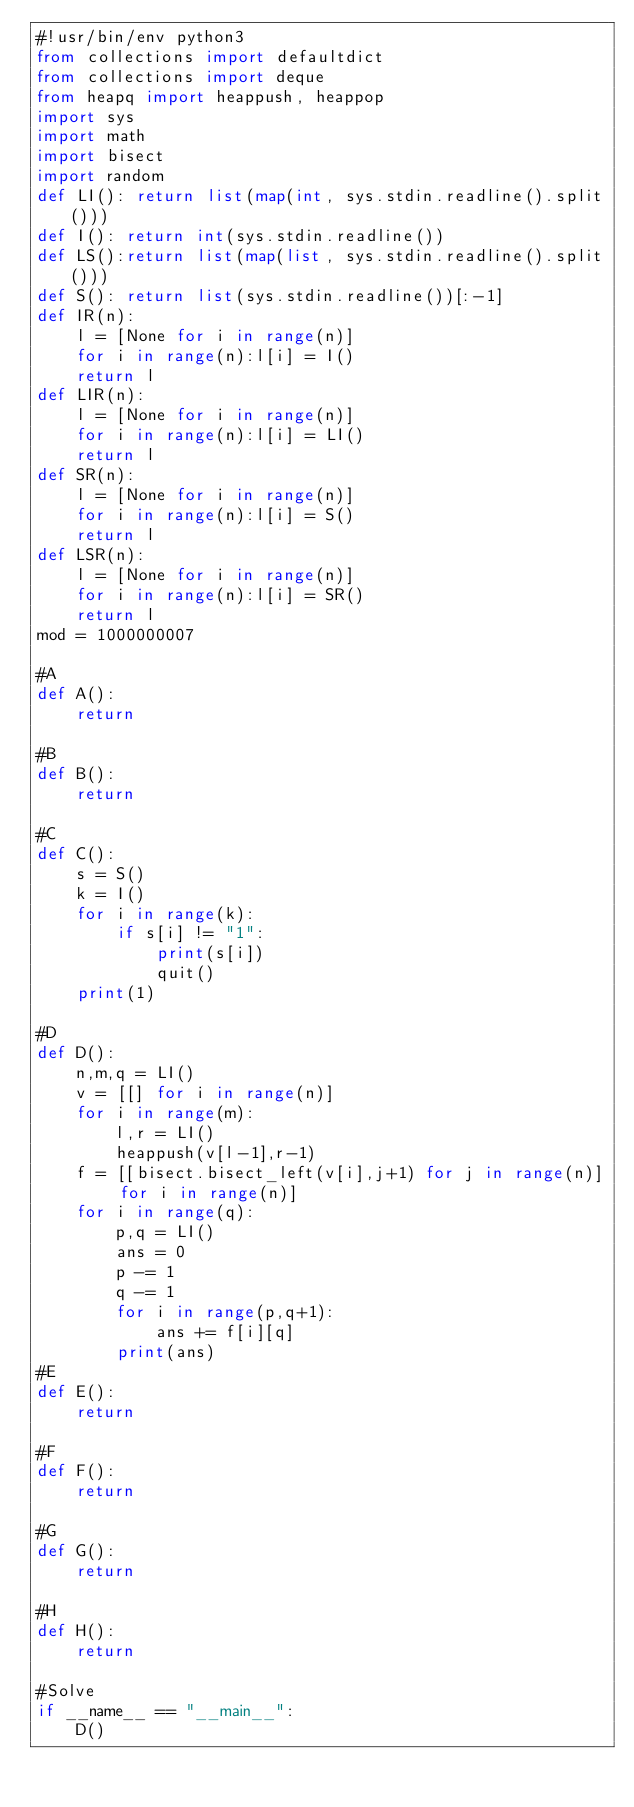Convert code to text. <code><loc_0><loc_0><loc_500><loc_500><_Python_>#!usr/bin/env python3
from collections import defaultdict
from collections import deque
from heapq import heappush, heappop
import sys
import math
import bisect
import random
def LI(): return list(map(int, sys.stdin.readline().split()))
def I(): return int(sys.stdin.readline())
def LS():return list(map(list, sys.stdin.readline().split()))
def S(): return list(sys.stdin.readline())[:-1]
def IR(n):
    l = [None for i in range(n)]
    for i in range(n):l[i] = I()
    return l
def LIR(n):
    l = [None for i in range(n)]
    for i in range(n):l[i] = LI()
    return l
def SR(n):
    l = [None for i in range(n)]
    for i in range(n):l[i] = S()
    return l
def LSR(n):
    l = [None for i in range(n)]
    for i in range(n):l[i] = SR()
    return l
mod = 1000000007

#A
def A():
    return

#B
def B():
    return

#C
def C():
    s = S()
    k = I()
    for i in range(k):
        if s[i] != "1":
            print(s[i])
            quit()
    print(1)

#D
def D():
    n,m,q = LI()
    v = [[] for i in range(n)]
    for i in range(m):
        l,r = LI()
        heappush(v[l-1],r-1)
    f = [[bisect.bisect_left(v[i],j+1) for j in range(n)] for i in range(n)]
    for i in range(q):
        p,q = LI()
        ans = 0
        p -= 1
        q -= 1
        for i in range(p,q+1):
            ans += f[i][q]
        print(ans)
#E
def E():
    return

#F
def F():
    return

#G
def G():
    return

#H
def H():
    return

#Solve
if __name__ == "__main__":
    D()
</code> 